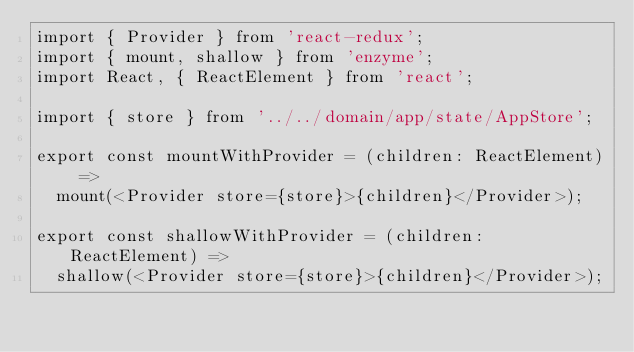<code> <loc_0><loc_0><loc_500><loc_500><_TypeScript_>import { Provider } from 'react-redux';
import { mount, shallow } from 'enzyme';
import React, { ReactElement } from 'react';

import { store } from '../../domain/app/state/AppStore';

export const mountWithProvider = (children: ReactElement) =>
  mount(<Provider store={store}>{children}</Provider>);

export const shallowWithProvider = (children: ReactElement) =>
  shallow(<Provider store={store}>{children}</Provider>);
</code> 